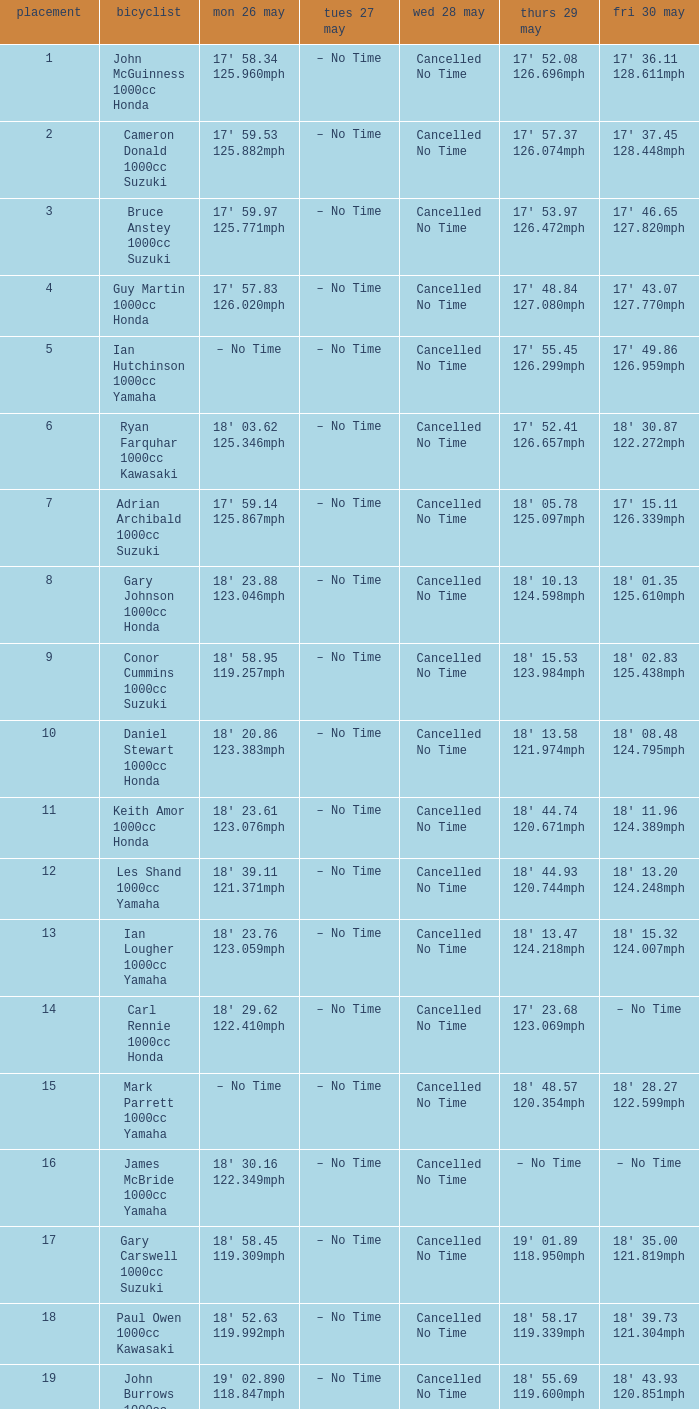Parse the full table. {'header': ['placement', 'bicyclist', 'mon 26 may', 'tues 27 may', 'wed 28 may', 'thurs 29 may', 'fri 30 may'], 'rows': [['1', 'John McGuinness 1000cc Honda', "17' 58.34 125.960mph", '– No Time', 'Cancelled No Time', "17' 52.08 126.696mph", "17' 36.11 128.611mph"], ['2', 'Cameron Donald 1000cc Suzuki', "17' 59.53 125.882mph", '– No Time', 'Cancelled No Time', "17' 57.37 126.074mph", "17' 37.45 128.448mph"], ['3', 'Bruce Anstey 1000cc Suzuki', "17' 59.97 125.771mph", '– No Time', 'Cancelled No Time', "17' 53.97 126.472mph", "17' 46.65 127.820mph"], ['4', 'Guy Martin 1000cc Honda', "17' 57.83 126.020mph", '– No Time', 'Cancelled No Time', "17' 48.84 127.080mph", "17' 43.07 127.770mph"], ['5', 'Ian Hutchinson 1000cc Yamaha', '– No Time', '– No Time', 'Cancelled No Time', "17' 55.45 126.299mph", "17' 49.86 126.959mph"], ['6', 'Ryan Farquhar 1000cc Kawasaki', "18' 03.62 125.346mph", '– No Time', 'Cancelled No Time', "17' 52.41 126.657mph", "18' 30.87 122.272mph"], ['7', 'Adrian Archibald 1000cc Suzuki', "17' 59.14 125.867mph", '– No Time', 'Cancelled No Time', "18' 05.78 125.097mph", "17' 15.11 126.339mph"], ['8', 'Gary Johnson 1000cc Honda', "18' 23.88 123.046mph", '– No Time', 'Cancelled No Time', "18' 10.13 124.598mph", "18' 01.35 125.610mph"], ['9', 'Conor Cummins 1000cc Suzuki', "18' 58.95 119.257mph", '– No Time', 'Cancelled No Time', "18' 15.53 123.984mph", "18' 02.83 125.438mph"], ['10', 'Daniel Stewart 1000cc Honda', "18' 20.86 123.383mph", '– No Time', 'Cancelled No Time', "18' 13.58 121.974mph", "18' 08.48 124.795mph"], ['11', 'Keith Amor 1000cc Honda', "18' 23.61 123.076mph", '– No Time', 'Cancelled No Time', "18' 44.74 120.671mph", "18' 11.96 124.389mph"], ['12', 'Les Shand 1000cc Yamaha', "18' 39.11 121.371mph", '– No Time', 'Cancelled No Time', "18' 44.93 120.744mph", "18' 13.20 124.248mph"], ['13', 'Ian Lougher 1000cc Yamaha', "18' 23.76 123.059mph", '– No Time', 'Cancelled No Time', "18' 13.47 124.218mph", "18' 15.32 124.007mph"], ['14', 'Carl Rennie 1000cc Honda', "18' 29.62 122.410mph", '– No Time', 'Cancelled No Time', "17' 23.68 123.069mph", '– No Time'], ['15', 'Mark Parrett 1000cc Yamaha', '– No Time', '– No Time', 'Cancelled No Time', "18' 48.57 120.354mph", "18' 28.27 122.599mph"], ['16', 'James McBride 1000cc Yamaha', "18' 30.16 122.349mph", '– No Time', 'Cancelled No Time', '– No Time', '– No Time'], ['17', 'Gary Carswell 1000cc Suzuki', "18' 58.45 119.309mph", '– No Time', 'Cancelled No Time', "19' 01.89 118.950mph", "18' 35.00 121.819mph"], ['18', 'Paul Owen 1000cc Kawasaki', "18' 52.63 119.992mph", '– No Time', 'Cancelled No Time', "18' 58.17 119.339mph", "18' 39.73 121.304mph"], ['19', 'John Burrows 1000cc Honda', "19' 02.890 118.847mph", '– No Time', 'Cancelled No Time', "18' 55.69 119.600mph", "18' 43.93 120.851mph"]]} What time is mon may 26 and fri may 30 is 18' 28.27 122.599mph? – No Time. 